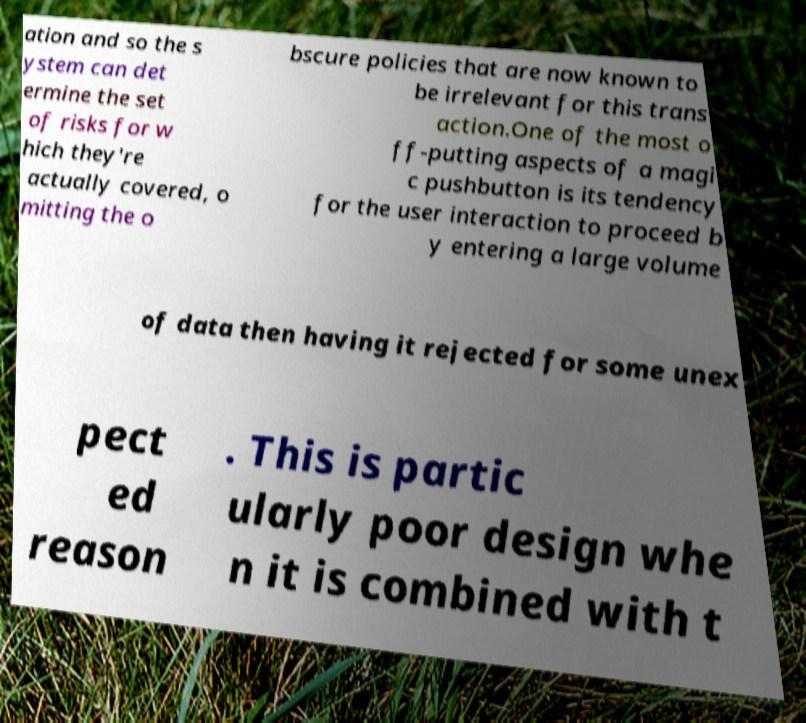What messages or text are displayed in this image? I need them in a readable, typed format. ation and so the s ystem can det ermine the set of risks for w hich they're actually covered, o mitting the o bscure policies that are now known to be irrelevant for this trans action.One of the most o ff-putting aspects of a magi c pushbutton is its tendency for the user interaction to proceed b y entering a large volume of data then having it rejected for some unex pect ed reason . This is partic ularly poor design whe n it is combined with t 